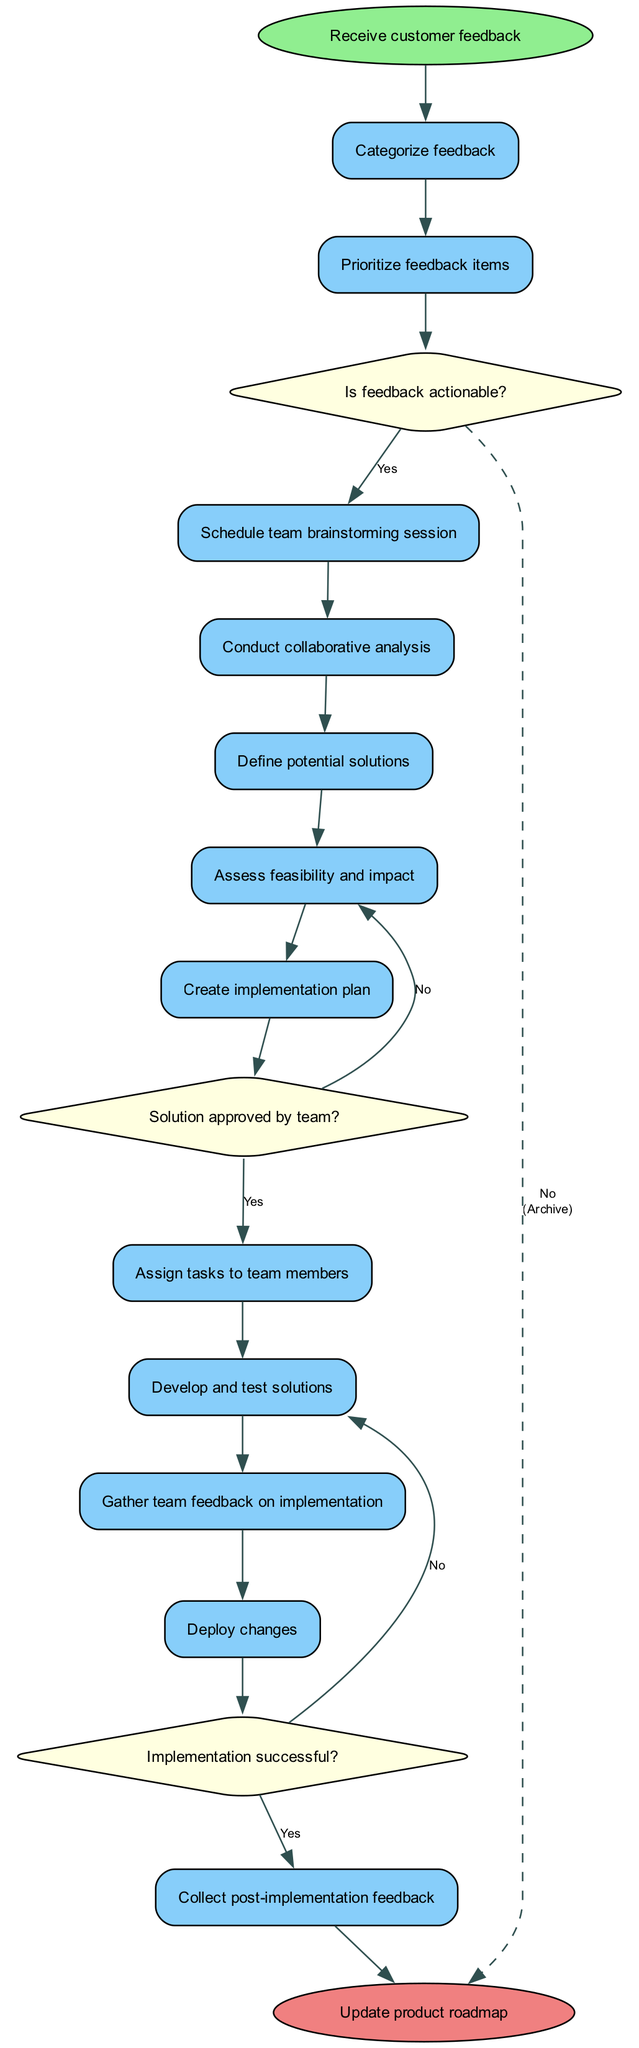What is the initial node in the diagram? The initial node is labeled "Receive customer feedback," which indicates the starting point of the activity cycle.
Answer: Receive customer feedback How many activities are there in total? By counting the items listed under the activities section in the diagram, we note there are 12 activities including the initial and final nodes.
Answer: 12 What happens if the feedback is not actionable? The diagram shows that if feedback is not actionable, the flow leads to an "Archive for future reference" node, indicating it is stored away and not acted upon.
Answer: Archive for future reference What is the decision made after assessing potential solutions? The next decision refers to whether the solution is approved by the team, which determines whether to proceed with creating an implementation plan or to refine potential solutions.
Answer: Solution approved by team? What activity follows "Conduct collaborative analysis"? The activity diagram outlines that after conducting collaborative analysis, the next activity is to define potential solutions.
Answer: Define potential solutions How many decisions are presented in the diagram? Upon examining the diagram, there are three decision points illustrated, each posing a key question that affects the flow of activities.
Answer: 3 What happens if the implementation is not successful? If the implementation is not successful, the flow directs back to "Reassess and adjust solution," indicating a return to refining the approach rather than moving to post-implementation feedback.
Answer: Reassess and adjust solution Which activity comes right before deploying changes? The diagram indicates that "Develop and test solutions" occurs immediately before the deployment of changes.
Answer: Develop and test solutions What is the final node in the cycle? The final node is labeled "Update product roadmap," showing that the cycle concludes with adjustments to the planning documents based on customer feedback implementation outcomes.
Answer: Update product roadmap 